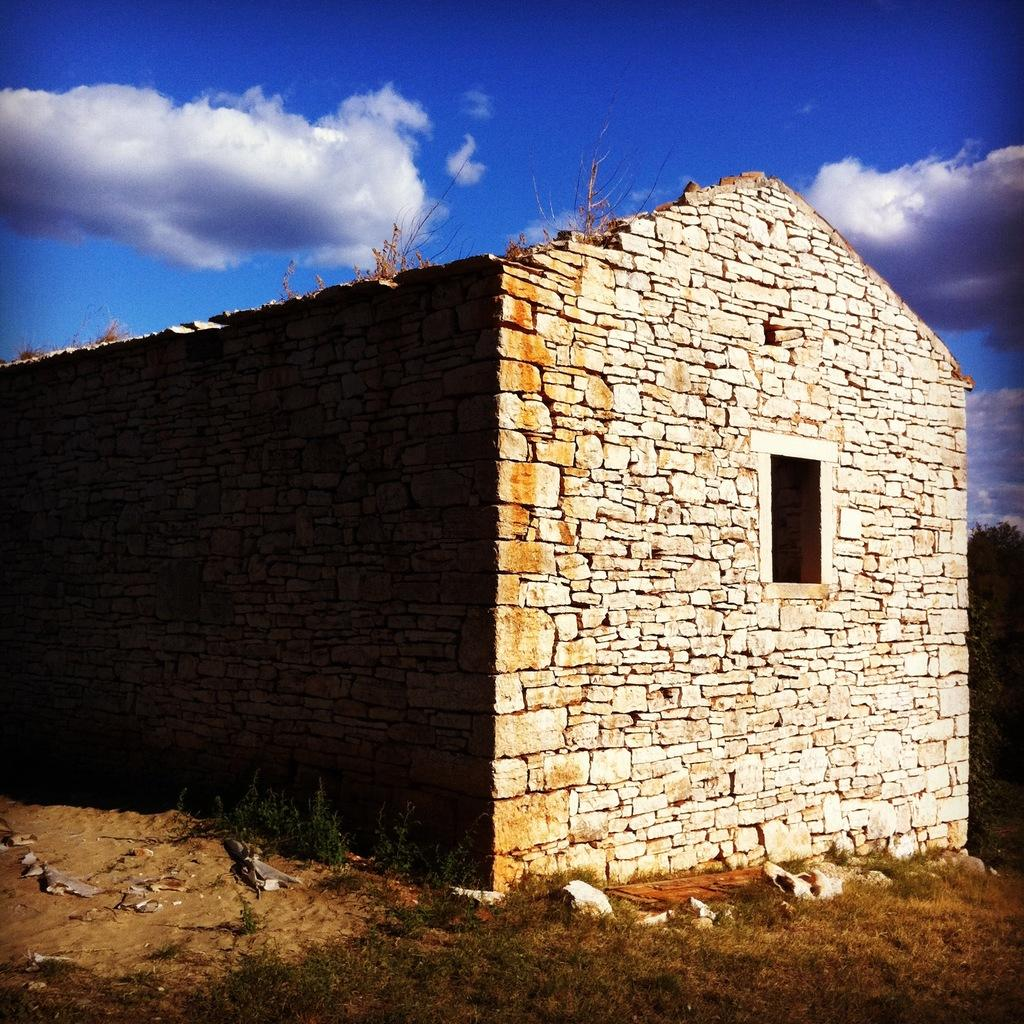What is the main structure in the foreground of the image? There is a house in the foreground of the image. What is the material of the house's wall? The house has a brick wall. What feature can be seen on the house? The house has a window. What type of vegetation is present in the image? There is grass in the image. What type of terrain is visible in the image? There is land in the image. What is visible in the sky in the image? The sky is visible in the image, and there are clouds in the sky. Can you tell me how many porters are carrying the ship at the dock in the image? There is no ship or dock present in the image; it features a house with a brick wall, a window, grass, land, and a sky with clouds. 